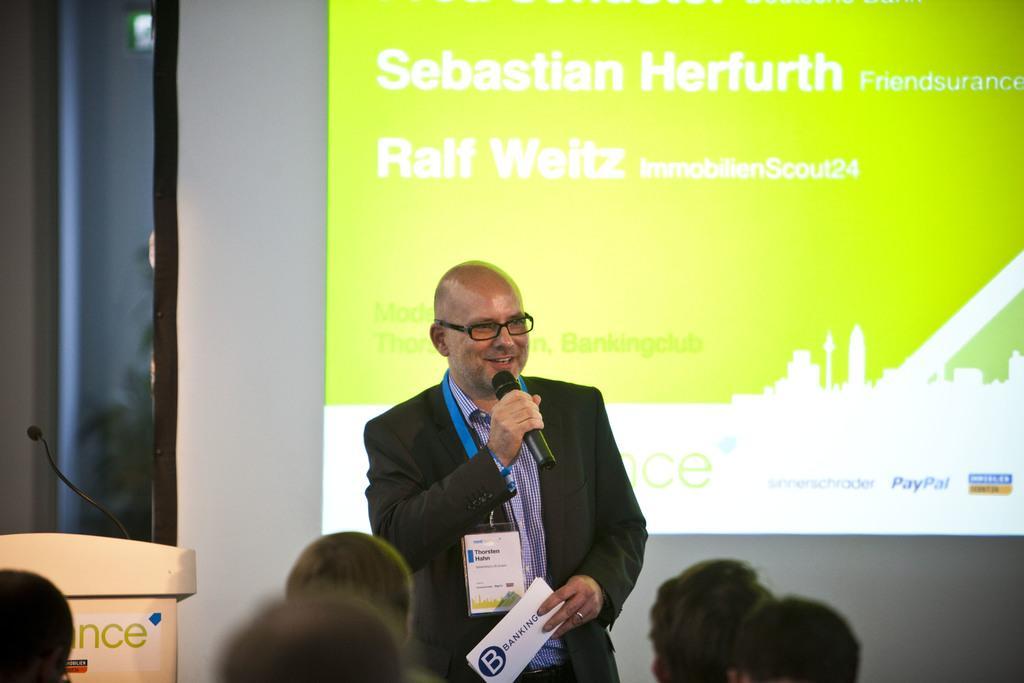Can you describe this image briefly? In this picture we can see a man wearing black coat standing and giving a speech holding a microphone in the hand. In front bottom side we can see a group of audience sitting and listening to hi. In the background we can see big projector screen. 